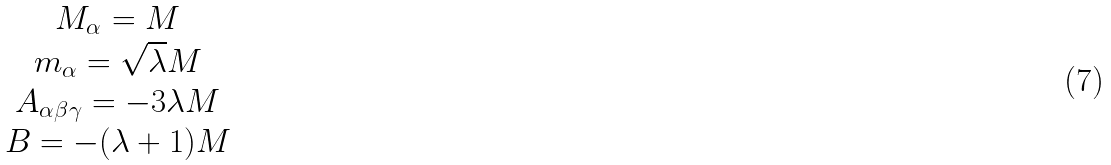Convert formula to latex. <formula><loc_0><loc_0><loc_500><loc_500>\begin{array} { c } M _ { \alpha } = M \\ m _ { \alpha } = \sqrt { \lambda } M \\ A _ { \alpha \beta \gamma } = - 3 \lambda M \\ B = - ( \lambda + 1 ) M \\ \end{array}</formula> 